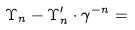<formula> <loc_0><loc_0><loc_500><loc_500>\Upsilon _ { n } - \Upsilon _ { n } ^ { \prime } \cdot \gamma ^ { - n } =</formula> 